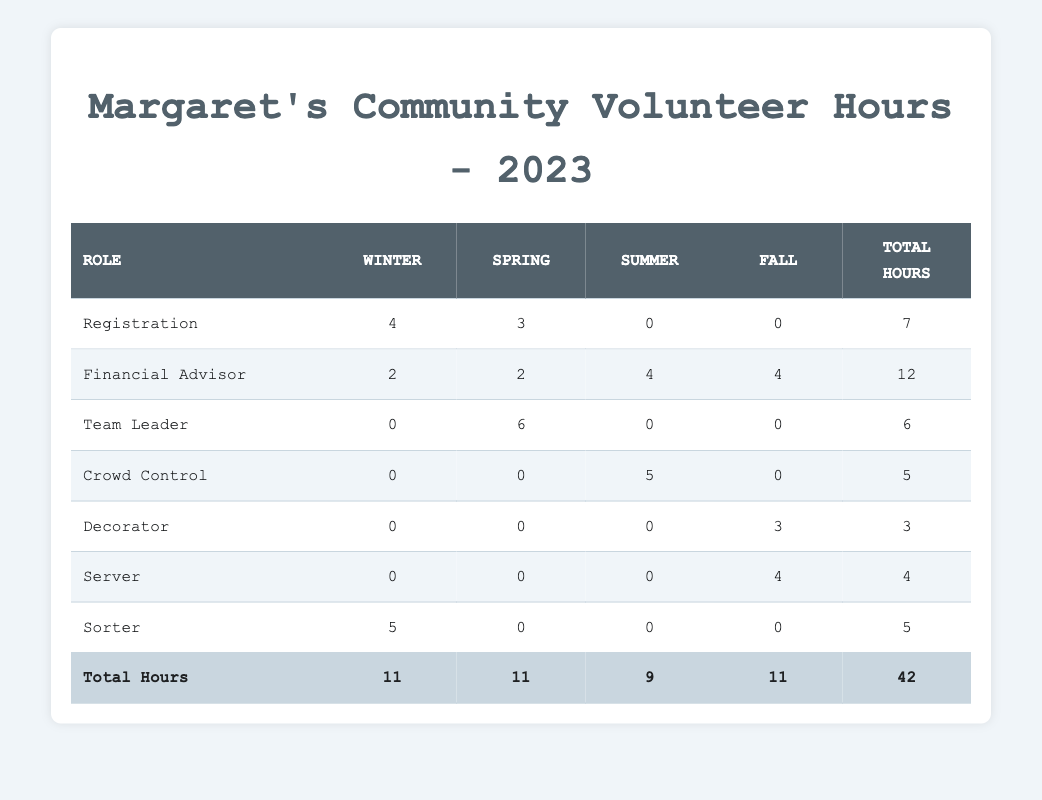What is the total number of hours Margaret volunteered in Winter? From the table, the total hours in the Winter column are 11, which is confirmed by the row marked "Total Hours." This value includes the contributions from "Registration" (4), "Financial Advisor" (2), and "Sorter" (5).
Answer: 11 How many hours did Margaret volunteer as a Team Leader? The table shows that as a Team Leader, Margaret volunteered for 6 hours during the Spring, and there are no contributions in other seasons.
Answer: 6 Did Margaret volunteer in every season? Examining the table reveals that Margaret didn't volunteer in Summer (0 hours for all roles) based on the absence of any contributions in the Summer column.
Answer: No What is the highest number of hours Margaret worked in a single role? By reviewing the "Total Hours" column, the "Financial Advisor" role has the highest total of 12 hours.
Answer: 12 Which season had the most cumulative volunteer hours for Margaret? Combining the hours across rows for each season: Winter has 11, Spring has 11, Summer has 9, and Fall has 11. Therefore, Winter, Spring, and Fall each have the most cumulative hours at 11.
Answer: Winter, Spring, and Fall How many hours did Margaret spend volunteering in the Fall compared to Summer? In the Fall, Margaret volunteered for 11 hours (combined from roles "Financial Advisor," "Server," and "Decorator"), while in Summer, she volunteered for 5 hours ("Crowd Control"). Thus, Margaret volunteered 6 more hours in Fall than in Summer.
Answer: 6 more hours in Fall What are the roles in which Margaret volunteered during the holiday events? The table shows that during the Holiday Toy Drive, she volunteered as "Sorter" (5 hours) and "Financial Advisor" (2 hours), totaling 7 hours for holiday activities.
Answer: Sorter and Financial Advisor What is the average number of hours Margaret volunteered per event? To find the average, we take the total hours worked (42) and divide it by the number of events (12). Thus, the average is calculated as 42 divided by 12, leading to 3.5 hours per event.
Answer: 3.5 How many hours did Margaret spend volunteering in the Halloween event compared to the Thanksgiving event? In the Halloween Trunk or Treat event, she volunteered for 3 hours (as a Decorator), while during the Thanksgiving Community Dinner, she worked for 6 hours in total (2 as Financial Advisor and 4 as Server). Thus, she spent 3 hours less on Halloween.
Answer: 3 hours less on Halloween 